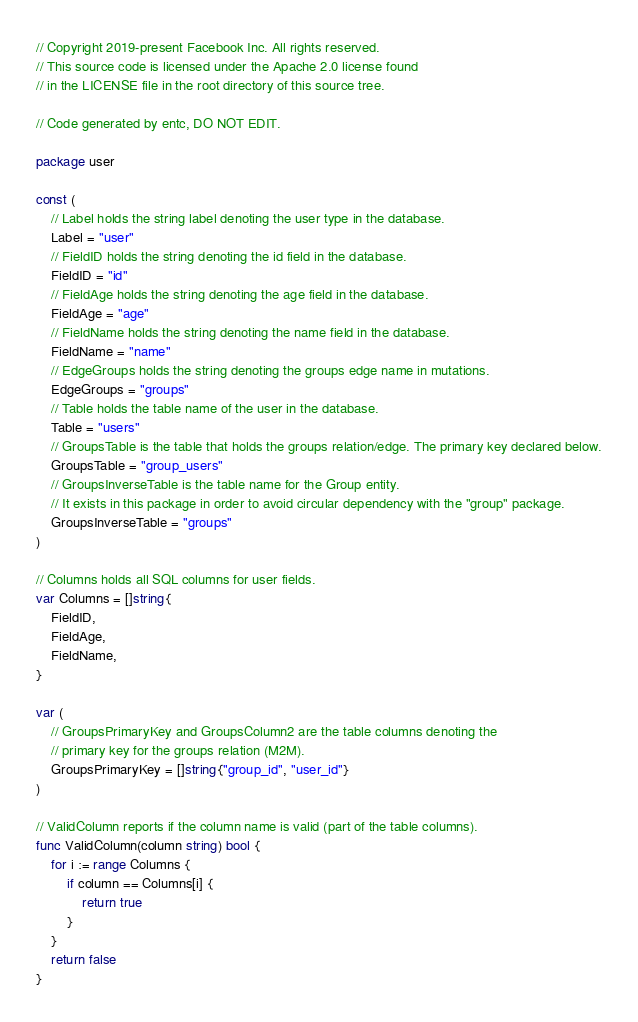Convert code to text. <code><loc_0><loc_0><loc_500><loc_500><_Go_>// Copyright 2019-present Facebook Inc. All rights reserved.
// This source code is licensed under the Apache 2.0 license found
// in the LICENSE file in the root directory of this source tree.

// Code generated by entc, DO NOT EDIT.

package user

const (
	// Label holds the string label denoting the user type in the database.
	Label = "user"
	// FieldID holds the string denoting the id field in the database.
	FieldID = "id"
	// FieldAge holds the string denoting the age field in the database.
	FieldAge = "age"
	// FieldName holds the string denoting the name field in the database.
	FieldName = "name"
	// EdgeGroups holds the string denoting the groups edge name in mutations.
	EdgeGroups = "groups"
	// Table holds the table name of the user in the database.
	Table = "users"
	// GroupsTable is the table that holds the groups relation/edge. The primary key declared below.
	GroupsTable = "group_users"
	// GroupsInverseTable is the table name for the Group entity.
	// It exists in this package in order to avoid circular dependency with the "group" package.
	GroupsInverseTable = "groups"
)

// Columns holds all SQL columns for user fields.
var Columns = []string{
	FieldID,
	FieldAge,
	FieldName,
}

var (
	// GroupsPrimaryKey and GroupsColumn2 are the table columns denoting the
	// primary key for the groups relation (M2M).
	GroupsPrimaryKey = []string{"group_id", "user_id"}
)

// ValidColumn reports if the column name is valid (part of the table columns).
func ValidColumn(column string) bool {
	for i := range Columns {
		if column == Columns[i] {
			return true
		}
	}
	return false
}
</code> 